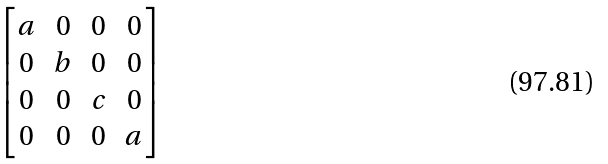Convert formula to latex. <formula><loc_0><loc_0><loc_500><loc_500>\begin{bmatrix} a & 0 & 0 & 0 \\ 0 & b & 0 & 0 \\ 0 & 0 & c & 0 \\ 0 & 0 & 0 & a \end{bmatrix}</formula> 